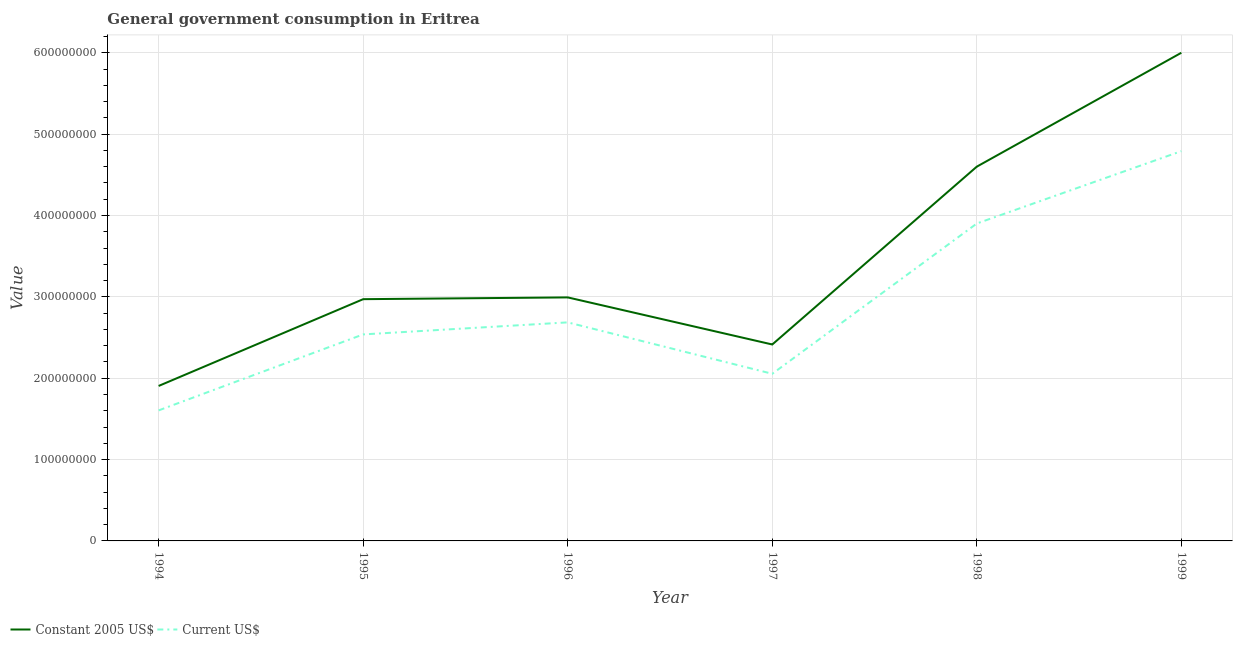How many different coloured lines are there?
Your answer should be very brief. 2. Does the line corresponding to value consumed in constant 2005 us$ intersect with the line corresponding to value consumed in current us$?
Your response must be concise. No. What is the value consumed in constant 2005 us$ in 1999?
Give a very brief answer. 6.00e+08. Across all years, what is the maximum value consumed in constant 2005 us$?
Offer a very short reply. 6.00e+08. Across all years, what is the minimum value consumed in current us$?
Offer a very short reply. 1.60e+08. What is the total value consumed in current us$ in the graph?
Provide a succinct answer. 1.76e+09. What is the difference between the value consumed in current us$ in 1997 and that in 1999?
Make the answer very short. -2.74e+08. What is the difference between the value consumed in current us$ in 1998 and the value consumed in constant 2005 us$ in 1994?
Your response must be concise. 2.00e+08. What is the average value consumed in constant 2005 us$ per year?
Keep it short and to the point. 3.48e+08. In the year 1994, what is the difference between the value consumed in current us$ and value consumed in constant 2005 us$?
Keep it short and to the point. -3.01e+07. What is the ratio of the value consumed in current us$ in 1995 to that in 1996?
Offer a terse response. 0.94. What is the difference between the highest and the second highest value consumed in constant 2005 us$?
Provide a succinct answer. 1.40e+08. What is the difference between the highest and the lowest value consumed in constant 2005 us$?
Provide a short and direct response. 4.10e+08. Is the sum of the value consumed in current us$ in 1994 and 1998 greater than the maximum value consumed in constant 2005 us$ across all years?
Your answer should be compact. No. Does the value consumed in constant 2005 us$ monotonically increase over the years?
Your answer should be very brief. No. Is the value consumed in constant 2005 us$ strictly greater than the value consumed in current us$ over the years?
Your answer should be very brief. Yes. Is the value consumed in current us$ strictly less than the value consumed in constant 2005 us$ over the years?
Give a very brief answer. Yes. How many lines are there?
Provide a short and direct response. 2. How many years are there in the graph?
Offer a terse response. 6. Does the graph contain grids?
Provide a short and direct response. Yes. What is the title of the graph?
Make the answer very short. General government consumption in Eritrea. What is the label or title of the Y-axis?
Offer a very short reply. Value. What is the Value in Constant 2005 US$ in 1994?
Keep it short and to the point. 1.90e+08. What is the Value of Current US$ in 1994?
Offer a terse response. 1.60e+08. What is the Value in Constant 2005 US$ in 1995?
Offer a terse response. 2.97e+08. What is the Value in Current US$ in 1995?
Offer a very short reply. 2.54e+08. What is the Value in Constant 2005 US$ in 1996?
Offer a very short reply. 2.99e+08. What is the Value in Current US$ in 1996?
Give a very brief answer. 2.69e+08. What is the Value of Constant 2005 US$ in 1997?
Offer a very short reply. 2.41e+08. What is the Value of Current US$ in 1997?
Offer a very short reply. 2.05e+08. What is the Value in Constant 2005 US$ in 1998?
Your answer should be compact. 4.60e+08. What is the Value of Current US$ in 1998?
Make the answer very short. 3.90e+08. What is the Value in Constant 2005 US$ in 1999?
Provide a short and direct response. 6.00e+08. What is the Value in Current US$ in 1999?
Offer a terse response. 4.79e+08. Across all years, what is the maximum Value in Constant 2005 US$?
Offer a very short reply. 6.00e+08. Across all years, what is the maximum Value in Current US$?
Give a very brief answer. 4.79e+08. Across all years, what is the minimum Value in Constant 2005 US$?
Your answer should be very brief. 1.90e+08. Across all years, what is the minimum Value of Current US$?
Provide a succinct answer. 1.60e+08. What is the total Value of Constant 2005 US$ in the graph?
Provide a short and direct response. 2.09e+09. What is the total Value in Current US$ in the graph?
Your answer should be compact. 1.76e+09. What is the difference between the Value of Constant 2005 US$ in 1994 and that in 1995?
Ensure brevity in your answer.  -1.07e+08. What is the difference between the Value in Current US$ in 1994 and that in 1995?
Offer a terse response. -9.34e+07. What is the difference between the Value of Constant 2005 US$ in 1994 and that in 1996?
Offer a very short reply. -1.09e+08. What is the difference between the Value of Current US$ in 1994 and that in 1996?
Make the answer very short. -1.08e+08. What is the difference between the Value in Constant 2005 US$ in 1994 and that in 1997?
Provide a short and direct response. -5.10e+07. What is the difference between the Value in Current US$ in 1994 and that in 1997?
Provide a short and direct response. -4.50e+07. What is the difference between the Value of Constant 2005 US$ in 1994 and that in 1998?
Give a very brief answer. -2.70e+08. What is the difference between the Value in Current US$ in 1994 and that in 1998?
Provide a short and direct response. -2.30e+08. What is the difference between the Value of Constant 2005 US$ in 1994 and that in 1999?
Provide a succinct answer. -4.10e+08. What is the difference between the Value of Current US$ in 1994 and that in 1999?
Your answer should be very brief. -3.19e+08. What is the difference between the Value in Constant 2005 US$ in 1995 and that in 1996?
Offer a very short reply. -2.18e+06. What is the difference between the Value in Current US$ in 1995 and that in 1996?
Make the answer very short. -1.48e+07. What is the difference between the Value in Constant 2005 US$ in 1995 and that in 1997?
Your answer should be compact. 5.57e+07. What is the difference between the Value in Current US$ in 1995 and that in 1997?
Give a very brief answer. 4.84e+07. What is the difference between the Value of Constant 2005 US$ in 1995 and that in 1998?
Offer a very short reply. -1.63e+08. What is the difference between the Value in Current US$ in 1995 and that in 1998?
Ensure brevity in your answer.  -1.36e+08. What is the difference between the Value in Constant 2005 US$ in 1995 and that in 1999?
Give a very brief answer. -3.03e+08. What is the difference between the Value in Current US$ in 1995 and that in 1999?
Provide a short and direct response. -2.25e+08. What is the difference between the Value of Constant 2005 US$ in 1996 and that in 1997?
Your response must be concise. 5.79e+07. What is the difference between the Value in Current US$ in 1996 and that in 1997?
Make the answer very short. 6.32e+07. What is the difference between the Value in Constant 2005 US$ in 1996 and that in 1998?
Make the answer very short. -1.61e+08. What is the difference between the Value in Current US$ in 1996 and that in 1998?
Offer a terse response. -1.22e+08. What is the difference between the Value in Constant 2005 US$ in 1996 and that in 1999?
Provide a short and direct response. -3.01e+08. What is the difference between the Value in Current US$ in 1996 and that in 1999?
Keep it short and to the point. -2.10e+08. What is the difference between the Value in Constant 2005 US$ in 1997 and that in 1998?
Give a very brief answer. -2.19e+08. What is the difference between the Value of Current US$ in 1997 and that in 1998?
Your answer should be very brief. -1.85e+08. What is the difference between the Value in Constant 2005 US$ in 1997 and that in 1999?
Make the answer very short. -3.59e+08. What is the difference between the Value in Current US$ in 1997 and that in 1999?
Your response must be concise. -2.74e+08. What is the difference between the Value of Constant 2005 US$ in 1998 and that in 1999?
Your response must be concise. -1.40e+08. What is the difference between the Value of Current US$ in 1998 and that in 1999?
Give a very brief answer. -8.89e+07. What is the difference between the Value of Constant 2005 US$ in 1994 and the Value of Current US$ in 1995?
Give a very brief answer. -6.33e+07. What is the difference between the Value of Constant 2005 US$ in 1994 and the Value of Current US$ in 1996?
Offer a very short reply. -7.82e+07. What is the difference between the Value in Constant 2005 US$ in 1994 and the Value in Current US$ in 1997?
Offer a very short reply. -1.49e+07. What is the difference between the Value in Constant 2005 US$ in 1994 and the Value in Current US$ in 1998?
Keep it short and to the point. -2.00e+08. What is the difference between the Value of Constant 2005 US$ in 1994 and the Value of Current US$ in 1999?
Make the answer very short. -2.89e+08. What is the difference between the Value in Constant 2005 US$ in 1995 and the Value in Current US$ in 1996?
Offer a terse response. 2.85e+07. What is the difference between the Value in Constant 2005 US$ in 1995 and the Value in Current US$ in 1997?
Give a very brief answer. 9.17e+07. What is the difference between the Value in Constant 2005 US$ in 1995 and the Value in Current US$ in 1998?
Your answer should be very brief. -9.30e+07. What is the difference between the Value of Constant 2005 US$ in 1995 and the Value of Current US$ in 1999?
Your answer should be very brief. -1.82e+08. What is the difference between the Value of Constant 2005 US$ in 1996 and the Value of Current US$ in 1997?
Provide a short and direct response. 9.39e+07. What is the difference between the Value of Constant 2005 US$ in 1996 and the Value of Current US$ in 1998?
Provide a short and direct response. -9.08e+07. What is the difference between the Value of Constant 2005 US$ in 1996 and the Value of Current US$ in 1999?
Your answer should be compact. -1.80e+08. What is the difference between the Value in Constant 2005 US$ in 1997 and the Value in Current US$ in 1998?
Provide a short and direct response. -1.49e+08. What is the difference between the Value in Constant 2005 US$ in 1997 and the Value in Current US$ in 1999?
Make the answer very short. -2.38e+08. What is the difference between the Value in Constant 2005 US$ in 1998 and the Value in Current US$ in 1999?
Your answer should be compact. -1.90e+07. What is the average Value of Constant 2005 US$ per year?
Make the answer very short. 3.48e+08. What is the average Value in Current US$ per year?
Make the answer very short. 2.93e+08. In the year 1994, what is the difference between the Value of Constant 2005 US$ and Value of Current US$?
Provide a succinct answer. 3.01e+07. In the year 1995, what is the difference between the Value of Constant 2005 US$ and Value of Current US$?
Keep it short and to the point. 4.33e+07. In the year 1996, what is the difference between the Value in Constant 2005 US$ and Value in Current US$?
Ensure brevity in your answer.  3.07e+07. In the year 1997, what is the difference between the Value in Constant 2005 US$ and Value in Current US$?
Provide a short and direct response. 3.60e+07. In the year 1998, what is the difference between the Value of Constant 2005 US$ and Value of Current US$?
Ensure brevity in your answer.  6.99e+07. In the year 1999, what is the difference between the Value in Constant 2005 US$ and Value in Current US$?
Make the answer very short. 1.21e+08. What is the ratio of the Value of Constant 2005 US$ in 1994 to that in 1995?
Your answer should be very brief. 0.64. What is the ratio of the Value in Current US$ in 1994 to that in 1995?
Your answer should be compact. 0.63. What is the ratio of the Value in Constant 2005 US$ in 1994 to that in 1996?
Provide a succinct answer. 0.64. What is the ratio of the Value in Current US$ in 1994 to that in 1996?
Make the answer very short. 0.6. What is the ratio of the Value in Constant 2005 US$ in 1994 to that in 1997?
Your response must be concise. 0.79. What is the ratio of the Value in Current US$ in 1994 to that in 1997?
Ensure brevity in your answer.  0.78. What is the ratio of the Value of Constant 2005 US$ in 1994 to that in 1998?
Offer a terse response. 0.41. What is the ratio of the Value in Current US$ in 1994 to that in 1998?
Your answer should be very brief. 0.41. What is the ratio of the Value in Constant 2005 US$ in 1994 to that in 1999?
Provide a succinct answer. 0.32. What is the ratio of the Value in Current US$ in 1994 to that in 1999?
Offer a very short reply. 0.33. What is the ratio of the Value of Constant 2005 US$ in 1995 to that in 1996?
Provide a short and direct response. 0.99. What is the ratio of the Value in Current US$ in 1995 to that in 1996?
Offer a terse response. 0.94. What is the ratio of the Value of Constant 2005 US$ in 1995 to that in 1997?
Give a very brief answer. 1.23. What is the ratio of the Value of Current US$ in 1995 to that in 1997?
Provide a succinct answer. 1.24. What is the ratio of the Value of Constant 2005 US$ in 1995 to that in 1998?
Your response must be concise. 0.65. What is the ratio of the Value in Current US$ in 1995 to that in 1998?
Give a very brief answer. 0.65. What is the ratio of the Value of Constant 2005 US$ in 1995 to that in 1999?
Your response must be concise. 0.5. What is the ratio of the Value in Current US$ in 1995 to that in 1999?
Provide a short and direct response. 0.53. What is the ratio of the Value of Constant 2005 US$ in 1996 to that in 1997?
Your answer should be very brief. 1.24. What is the ratio of the Value in Current US$ in 1996 to that in 1997?
Your answer should be very brief. 1.31. What is the ratio of the Value of Constant 2005 US$ in 1996 to that in 1998?
Provide a short and direct response. 0.65. What is the ratio of the Value in Current US$ in 1996 to that in 1998?
Offer a very short reply. 0.69. What is the ratio of the Value in Constant 2005 US$ in 1996 to that in 1999?
Keep it short and to the point. 0.5. What is the ratio of the Value in Current US$ in 1996 to that in 1999?
Provide a succinct answer. 0.56. What is the ratio of the Value in Constant 2005 US$ in 1997 to that in 1998?
Offer a very short reply. 0.52. What is the ratio of the Value of Current US$ in 1997 to that in 1998?
Give a very brief answer. 0.53. What is the ratio of the Value in Constant 2005 US$ in 1997 to that in 1999?
Give a very brief answer. 0.4. What is the ratio of the Value of Current US$ in 1997 to that in 1999?
Give a very brief answer. 0.43. What is the ratio of the Value in Constant 2005 US$ in 1998 to that in 1999?
Offer a very short reply. 0.77. What is the ratio of the Value in Current US$ in 1998 to that in 1999?
Ensure brevity in your answer.  0.81. What is the difference between the highest and the second highest Value of Constant 2005 US$?
Your answer should be compact. 1.40e+08. What is the difference between the highest and the second highest Value of Current US$?
Offer a very short reply. 8.89e+07. What is the difference between the highest and the lowest Value in Constant 2005 US$?
Your answer should be very brief. 4.10e+08. What is the difference between the highest and the lowest Value of Current US$?
Your answer should be compact. 3.19e+08. 